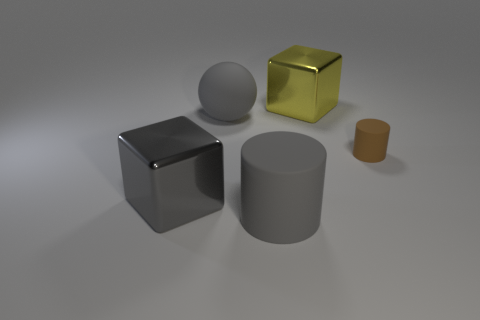Add 5 brown cylinders. How many objects exist? 10 Subtract all blocks. How many objects are left? 3 Add 4 big matte spheres. How many big matte spheres are left? 5 Add 1 gray objects. How many gray objects exist? 4 Subtract 0 purple balls. How many objects are left? 5 Subtract all tiny brown objects. Subtract all small matte objects. How many objects are left? 3 